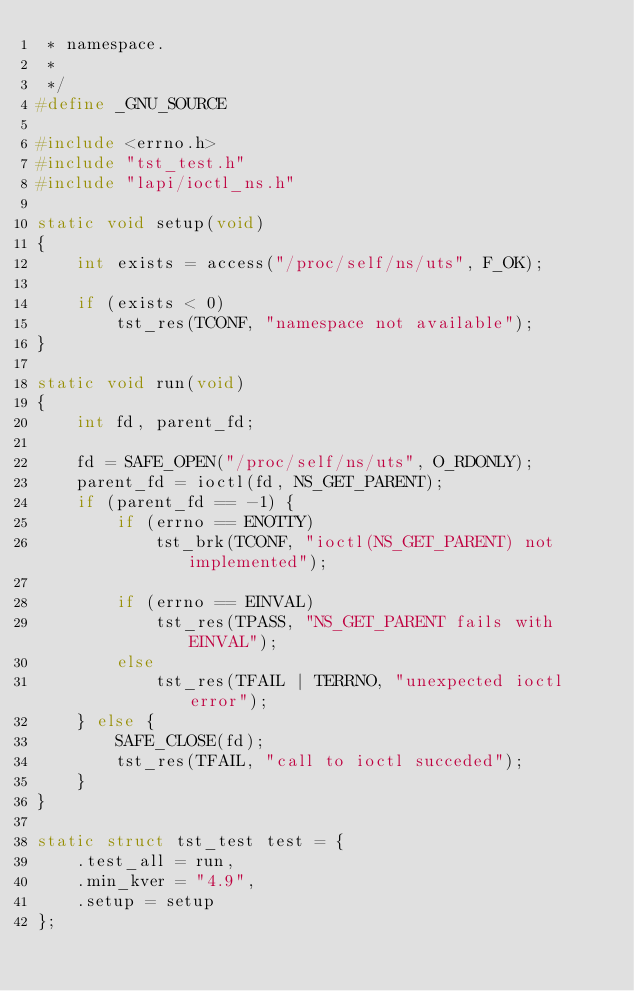Convert code to text. <code><loc_0><loc_0><loc_500><loc_500><_C_> * namespace.
 *
 */
#define _GNU_SOURCE

#include <errno.h>
#include "tst_test.h"
#include "lapi/ioctl_ns.h"

static void setup(void)
{
	int exists = access("/proc/self/ns/uts", F_OK);

	if (exists < 0)
		tst_res(TCONF, "namespace not available");
}

static void run(void)
{
	int fd, parent_fd;

	fd = SAFE_OPEN("/proc/self/ns/uts", O_RDONLY);
	parent_fd = ioctl(fd, NS_GET_PARENT);
	if (parent_fd == -1) {
		if (errno == ENOTTY)
			tst_brk(TCONF, "ioctl(NS_GET_PARENT) not implemented");

		if (errno == EINVAL)
			tst_res(TPASS, "NS_GET_PARENT fails with EINVAL");
		else
			tst_res(TFAIL | TERRNO, "unexpected ioctl error");
	} else {
		SAFE_CLOSE(fd);
		tst_res(TFAIL, "call to ioctl succeded");
	}
}

static struct tst_test test = {
	.test_all = run,
	.min_kver = "4.9",
	.setup = setup
};
</code> 